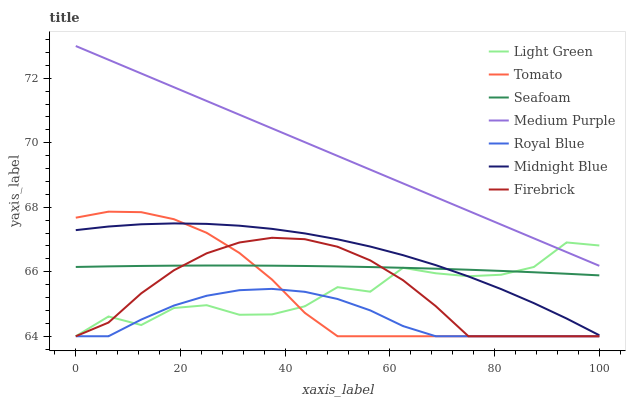Does Midnight Blue have the minimum area under the curve?
Answer yes or no. No. Does Midnight Blue have the maximum area under the curve?
Answer yes or no. No. Is Midnight Blue the smoothest?
Answer yes or no. No. Is Midnight Blue the roughest?
Answer yes or no. No. Does Midnight Blue have the lowest value?
Answer yes or no. No. Does Midnight Blue have the highest value?
Answer yes or no. No. Is Royal Blue less than Midnight Blue?
Answer yes or no. Yes. Is Medium Purple greater than Seafoam?
Answer yes or no. Yes. Does Royal Blue intersect Midnight Blue?
Answer yes or no. No. 